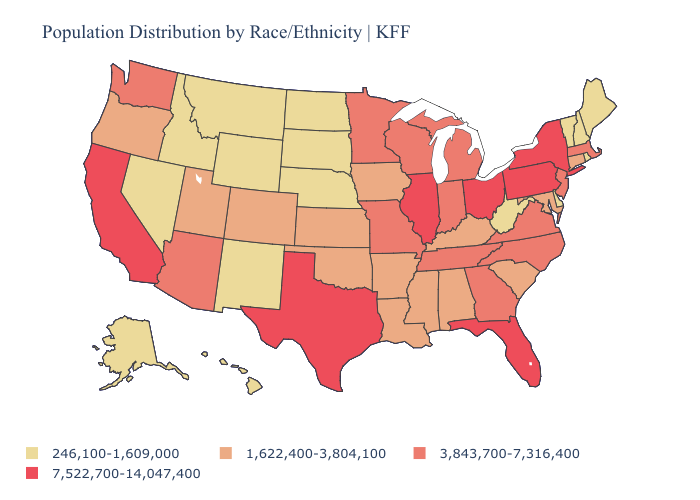What is the highest value in the USA?
Be succinct. 7,522,700-14,047,400. Which states have the lowest value in the Northeast?
Keep it brief. Maine, New Hampshire, Rhode Island, Vermont. Does Hawaii have the lowest value in the USA?
Answer briefly. Yes. Name the states that have a value in the range 7,522,700-14,047,400?
Concise answer only. California, Florida, Illinois, New York, Ohio, Pennsylvania, Texas. Does South Carolina have a higher value than Indiana?
Quick response, please. No. Name the states that have a value in the range 3,843,700-7,316,400?
Answer briefly. Arizona, Georgia, Indiana, Massachusetts, Michigan, Minnesota, Missouri, New Jersey, North Carolina, Tennessee, Virginia, Washington, Wisconsin. What is the highest value in the South ?
Quick response, please. 7,522,700-14,047,400. Name the states that have a value in the range 7,522,700-14,047,400?
Keep it brief. California, Florida, Illinois, New York, Ohio, Pennsylvania, Texas. Does California have the highest value in the West?
Answer briefly. Yes. Does the map have missing data?
Quick response, please. No. What is the value of North Carolina?
Write a very short answer. 3,843,700-7,316,400. What is the lowest value in the West?
Short answer required. 246,100-1,609,000. Does Oregon have a higher value than Wisconsin?
Keep it brief. No. What is the lowest value in states that border Michigan?
Give a very brief answer. 3,843,700-7,316,400. Does Rhode Island have the highest value in the USA?
Concise answer only. No. 